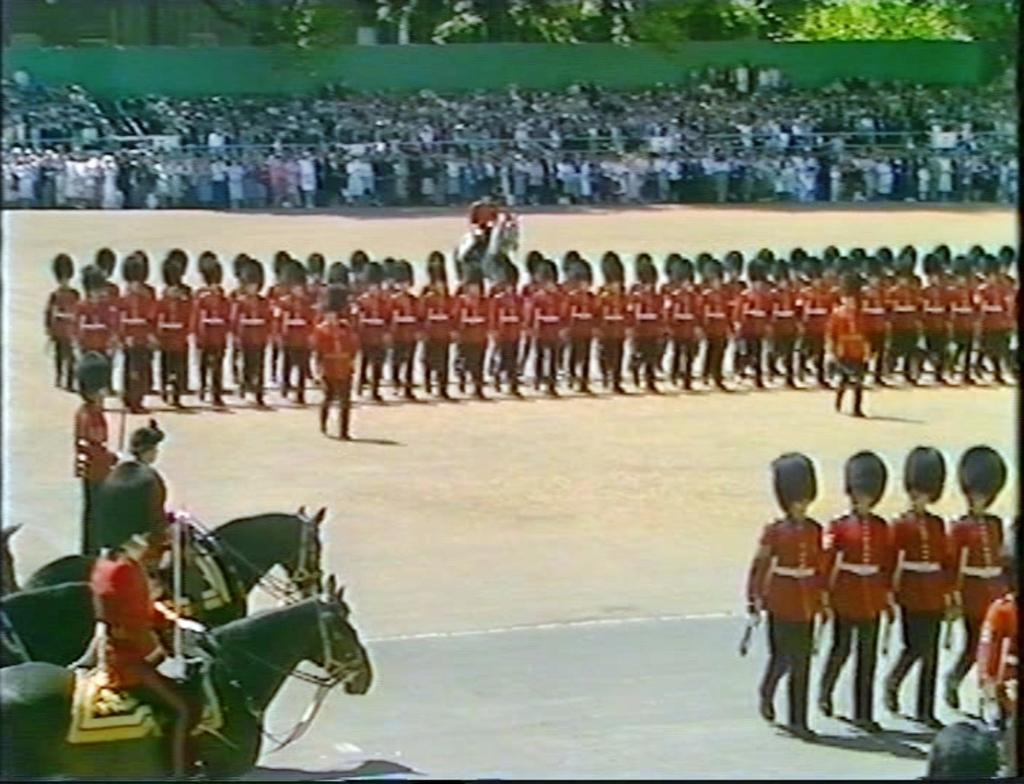Who or what can be seen in the image? There are people and crows visible in the image. What are the people doing in the image? Three people are sitting on horses in the image. What type of vegetation is present in the image? There are trees in the image. What type of box can be seen containing honey in the image? There is no box or honey present in the image. How is the mark on the crow's feathers affecting its flight in the image? There is no mention of a mark on the crow's feathers or any impact on its flight in the image. 